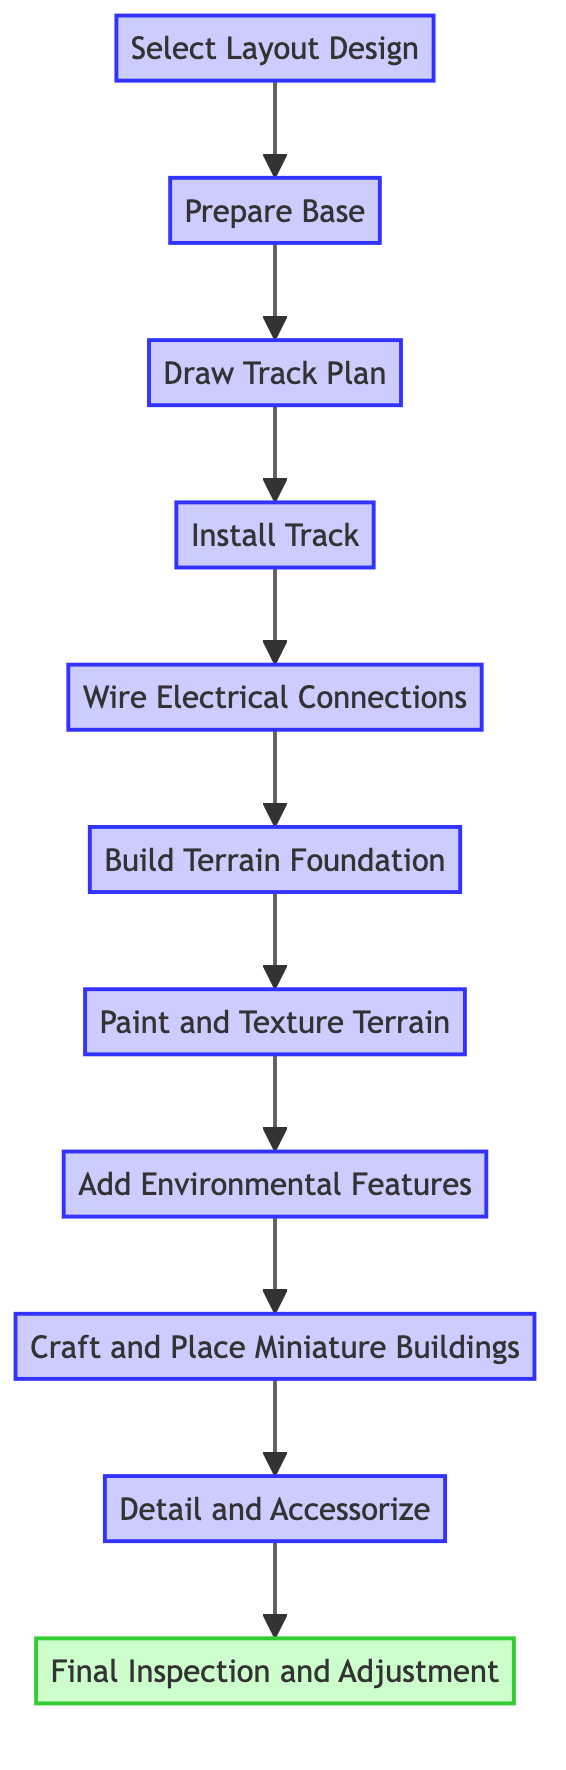What is the first step in the assembly process? The first step in the flow chart is represented by the node labeled "Select Layout Design." This node is the starting point of the assembly process and indicates that choosing the layout design is the initial action.
Answer: Select Layout Design How many steps are shown in the flow chart? Counting the nodes in the diagram, there are a total of 11 steps, from "Select Layout Design" to "Final Inspection and Adjustment." Each node represents a distinct step in the assembly process.
Answer: 11 What comes immediately after "Draw Track Plan"? The flow chart indicates that the node after "Draw Track Plan" is "Install Track." This shows the direct sequence in the assembly process following the planning stage.
Answer: Install Track Which step involves adding the final details? The step responsible for adding the final details is "Detail and Accessorize." This node indicates the last phase of embellishing the model train set terrain.
Answer: Detail and Accessorize What is the last step in the assembly process? The final step in the flow chart is "Final Inspection and Adjustment." This denotes the concluding action where the entire assembly is inspected for consistency and functionality.
Answer: Final Inspection and Adjustment What step occurs before "Add Environmental Features"? Referring to the flow chart, the step that occurs before "Add Environmental Features" is "Paint and Texture Terrain." This shows the sequence that textures and paints the terrain before environmental elements are added.
Answer: Paint and Texture Terrain Which node describes the construction of basic terrain features? The node that describes the construction of basic terrain features is "Build Terrain Foundation." This indicates the step where initial terrain structures are created using various materials.
Answer: Build Terrain Foundation What two steps are connected directly? The steps "Wire Electrical Connections" and "Build Terrain Foundation" are directly connected via an arrow in the diagram, indicating the progression from wiring to terrain building.
Answer: Wire Electrical Connections, Build Terrain Foundation What kind of features are installed in the step "Add Environmental Features"? In the "Add Environmental Features" step, elements such as trees, bushes, and rocks are installed to enhance realism. This indicates what specific additions are made to the terrain.
Answer: Trees, bushes, rocks 